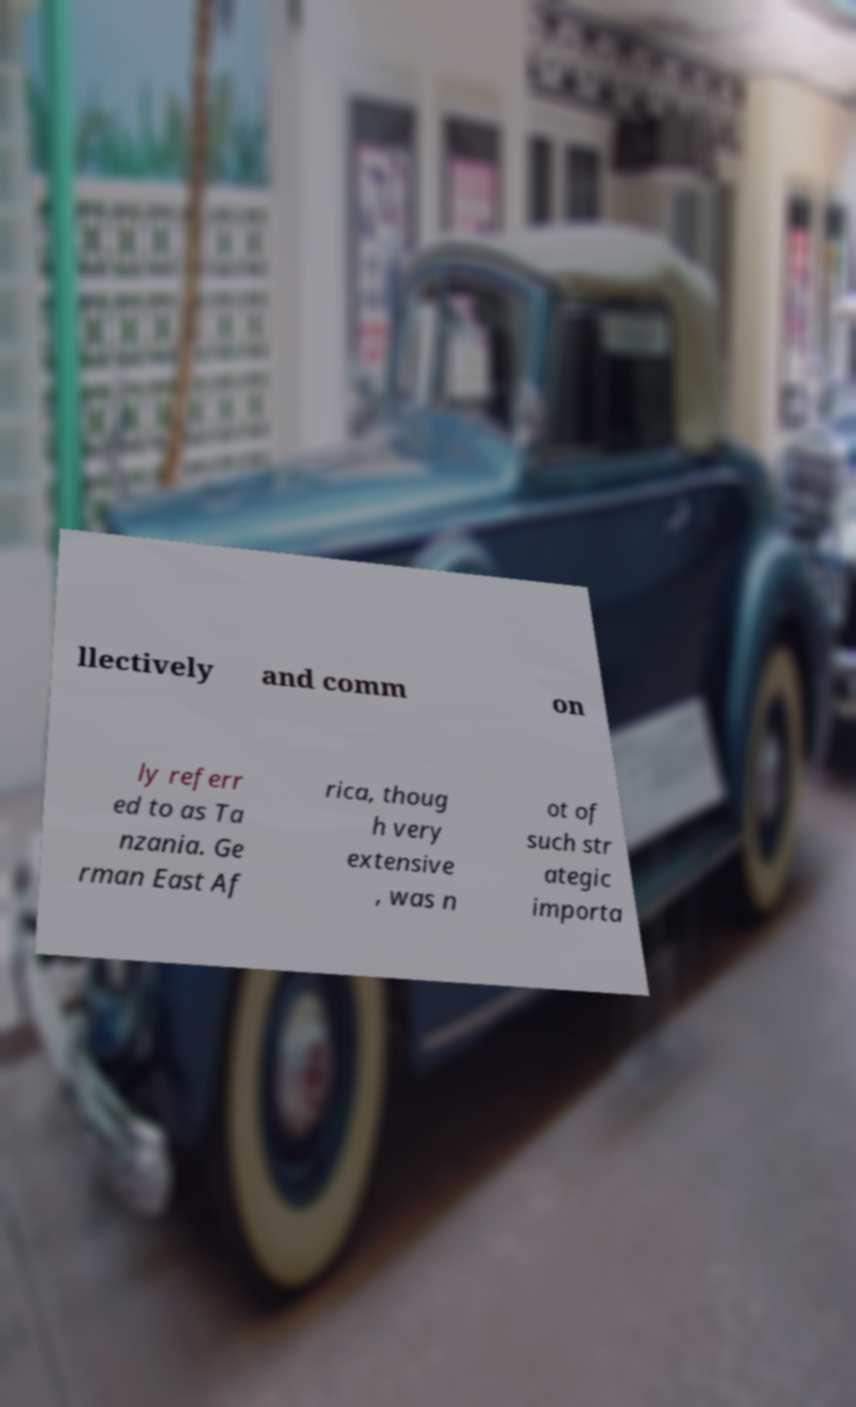What messages or text are displayed in this image? I need them in a readable, typed format. llectively and comm on ly referr ed to as Ta nzania. Ge rman East Af rica, thoug h very extensive , was n ot of such str ategic importa 